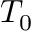Convert formula to latex. <formula><loc_0><loc_0><loc_500><loc_500>T _ { 0 }</formula> 